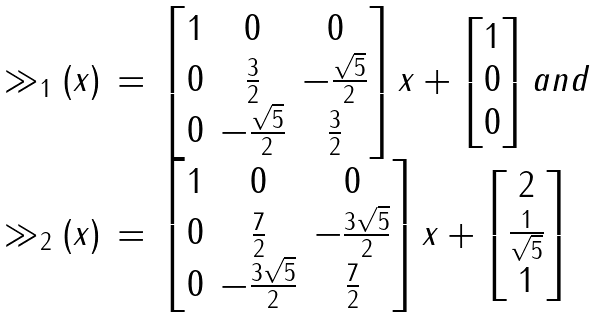<formula> <loc_0><loc_0><loc_500><loc_500>\begin{array} { r c l } \gg _ { 1 } ( x ) & = & \begin{bmatrix} 1 & 0 & 0 \\ 0 & \frac { 3 } { 2 } & - \frac { \sqrt { 5 } } { 2 } \\ 0 & - \frac { \sqrt { 5 } } { 2 } & \frac { 3 } { 2 } \end{bmatrix} x + \begin{bmatrix} 1 \\ 0 \\ 0 \end{bmatrix} a n d \\ \gg _ { 2 } ( x ) & = & \begin{bmatrix} 1 & 0 & 0 \\ 0 & \frac { 7 } { 2 } & - \frac { 3 \sqrt { 5 } } { 2 } \\ 0 & - \frac { 3 \sqrt { 5 } } { 2 } & \frac { 7 } { 2 } \end{bmatrix} x + \begin{bmatrix} 2 \\ \frac { 1 } { \sqrt { 5 } } \\ 1 \end{bmatrix} \end{array}</formula> 